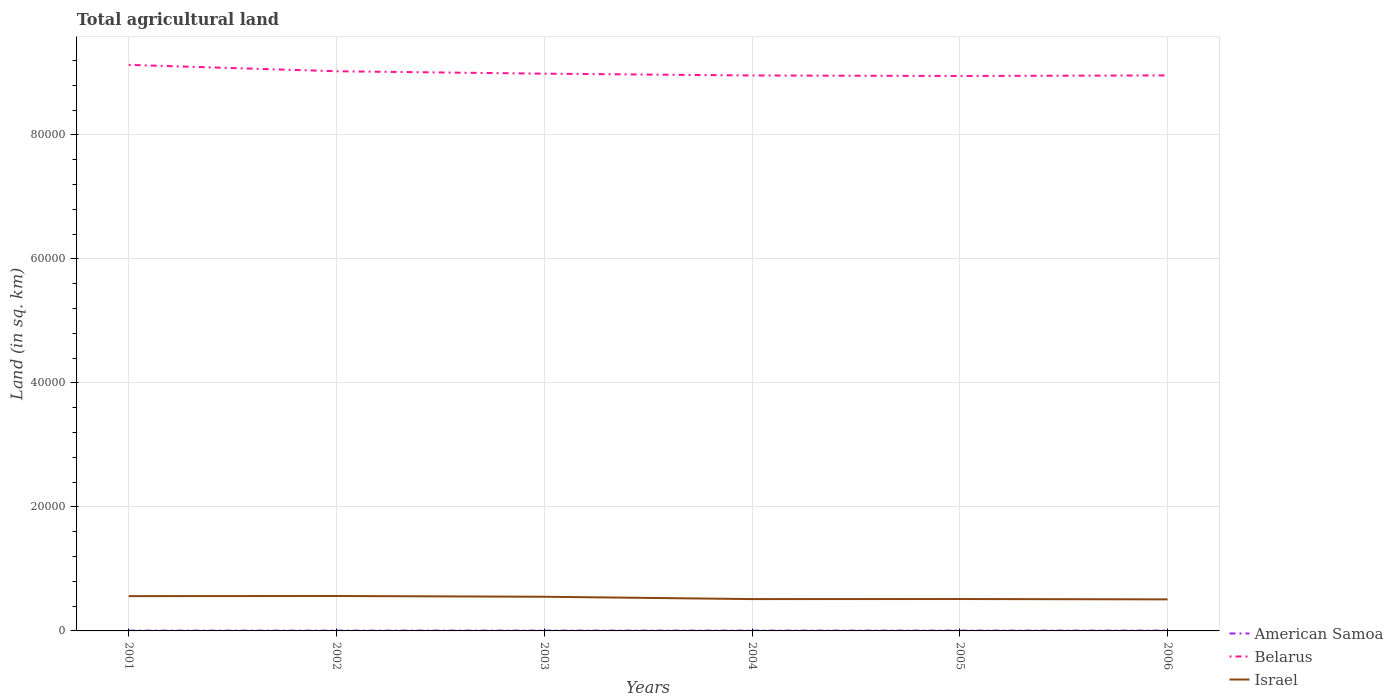How many different coloured lines are there?
Your response must be concise. 3. Does the line corresponding to Belarus intersect with the line corresponding to American Samoa?
Provide a succinct answer. No. Is the number of lines equal to the number of legend labels?
Make the answer very short. Yes. Across all years, what is the maximum total agricultural land in Israel?
Offer a terse response. 5088. In which year was the total agricultural land in Belarus maximum?
Give a very brief answer. 2005. What is the total total agricultural land in American Samoa in the graph?
Make the answer very short. 0.4. What is the difference between the highest and the second highest total agricultural land in Belarus?
Your response must be concise. 1790. Is the total agricultural land in Belarus strictly greater than the total agricultural land in American Samoa over the years?
Your answer should be compact. No. How many lines are there?
Ensure brevity in your answer.  3. How many years are there in the graph?
Give a very brief answer. 6. What is the difference between two consecutive major ticks on the Y-axis?
Your response must be concise. 2.00e+04. Does the graph contain any zero values?
Provide a short and direct response. No. Does the graph contain grids?
Your answer should be compact. Yes. How are the legend labels stacked?
Your response must be concise. Vertical. What is the title of the graph?
Give a very brief answer. Total agricultural land. What is the label or title of the Y-axis?
Offer a very short reply. Land (in sq. km). What is the Land (in sq. km) of Belarus in 2001?
Provide a short and direct response. 9.13e+04. What is the Land (in sq. km) in Israel in 2001?
Your answer should be very brief. 5610. What is the Land (in sq. km) in Belarus in 2002?
Offer a terse response. 9.02e+04. What is the Land (in sq. km) of Israel in 2002?
Offer a very short reply. 5630. What is the Land (in sq. km) of American Samoa in 2003?
Your response must be concise. 50.4. What is the Land (in sq. km) in Belarus in 2003?
Provide a succinct answer. 8.99e+04. What is the Land (in sq. km) of Israel in 2003?
Your answer should be very brief. 5510. What is the Land (in sq. km) in American Samoa in 2004?
Your answer should be compact. 50. What is the Land (in sq. km) in Belarus in 2004?
Provide a short and direct response. 8.96e+04. What is the Land (in sq. km) of Israel in 2004?
Provide a succinct answer. 5135. What is the Land (in sq. km) of American Samoa in 2005?
Make the answer very short. 50. What is the Land (in sq. km) in Belarus in 2005?
Your response must be concise. 8.95e+04. What is the Land (in sq. km) of Israel in 2005?
Ensure brevity in your answer.  5145. What is the Land (in sq. km) of American Samoa in 2006?
Ensure brevity in your answer.  50. What is the Land (in sq. km) of Belarus in 2006?
Offer a very short reply. 8.96e+04. What is the Land (in sq. km) of Israel in 2006?
Keep it short and to the point. 5088. Across all years, what is the maximum Land (in sq. km) in American Samoa?
Provide a short and direct response. 50.4. Across all years, what is the maximum Land (in sq. km) of Belarus?
Give a very brief answer. 9.13e+04. Across all years, what is the maximum Land (in sq. km) in Israel?
Offer a very short reply. 5630. Across all years, what is the minimum Land (in sq. km) of Belarus?
Give a very brief answer. 8.95e+04. Across all years, what is the minimum Land (in sq. km) in Israel?
Ensure brevity in your answer.  5088. What is the total Land (in sq. km) in American Samoa in the graph?
Your answer should be compact. 290.4. What is the total Land (in sq. km) in Belarus in the graph?
Your answer should be compact. 5.40e+05. What is the total Land (in sq. km) of Israel in the graph?
Provide a short and direct response. 3.21e+04. What is the difference between the Land (in sq. km) in American Samoa in 2001 and that in 2002?
Give a very brief answer. 0. What is the difference between the Land (in sq. km) of Belarus in 2001 and that in 2002?
Make the answer very short. 1030. What is the difference between the Land (in sq. km) of American Samoa in 2001 and that in 2003?
Ensure brevity in your answer.  -5.4. What is the difference between the Land (in sq. km) in Belarus in 2001 and that in 2003?
Keep it short and to the point. 1420. What is the difference between the Land (in sq. km) in American Samoa in 2001 and that in 2004?
Ensure brevity in your answer.  -5. What is the difference between the Land (in sq. km) in Belarus in 2001 and that in 2004?
Your answer should be compact. 1710. What is the difference between the Land (in sq. km) in Israel in 2001 and that in 2004?
Offer a very short reply. 475. What is the difference between the Land (in sq. km) of Belarus in 2001 and that in 2005?
Provide a short and direct response. 1790. What is the difference between the Land (in sq. km) in Israel in 2001 and that in 2005?
Provide a succinct answer. 465. What is the difference between the Land (in sq. km) of Belarus in 2001 and that in 2006?
Ensure brevity in your answer.  1700. What is the difference between the Land (in sq. km) of Israel in 2001 and that in 2006?
Offer a terse response. 522. What is the difference between the Land (in sq. km) in American Samoa in 2002 and that in 2003?
Keep it short and to the point. -5.4. What is the difference between the Land (in sq. km) of Belarus in 2002 and that in 2003?
Provide a short and direct response. 390. What is the difference between the Land (in sq. km) in Israel in 2002 and that in 2003?
Ensure brevity in your answer.  120. What is the difference between the Land (in sq. km) of American Samoa in 2002 and that in 2004?
Offer a very short reply. -5. What is the difference between the Land (in sq. km) of Belarus in 2002 and that in 2004?
Your answer should be very brief. 680. What is the difference between the Land (in sq. km) of Israel in 2002 and that in 2004?
Provide a succinct answer. 495. What is the difference between the Land (in sq. km) in Belarus in 2002 and that in 2005?
Provide a short and direct response. 760. What is the difference between the Land (in sq. km) in Israel in 2002 and that in 2005?
Your response must be concise. 485. What is the difference between the Land (in sq. km) of Belarus in 2002 and that in 2006?
Give a very brief answer. 670. What is the difference between the Land (in sq. km) in Israel in 2002 and that in 2006?
Keep it short and to the point. 542. What is the difference between the Land (in sq. km) in American Samoa in 2003 and that in 2004?
Provide a succinct answer. 0.4. What is the difference between the Land (in sq. km) of Belarus in 2003 and that in 2004?
Provide a short and direct response. 290. What is the difference between the Land (in sq. km) in Israel in 2003 and that in 2004?
Keep it short and to the point. 375. What is the difference between the Land (in sq. km) of American Samoa in 2003 and that in 2005?
Make the answer very short. 0.4. What is the difference between the Land (in sq. km) of Belarus in 2003 and that in 2005?
Your response must be concise. 370. What is the difference between the Land (in sq. km) in Israel in 2003 and that in 2005?
Your answer should be very brief. 365. What is the difference between the Land (in sq. km) of American Samoa in 2003 and that in 2006?
Your answer should be compact. 0.4. What is the difference between the Land (in sq. km) of Belarus in 2003 and that in 2006?
Keep it short and to the point. 280. What is the difference between the Land (in sq. km) of Israel in 2003 and that in 2006?
Provide a short and direct response. 422. What is the difference between the Land (in sq. km) in American Samoa in 2004 and that in 2005?
Your answer should be compact. 0. What is the difference between the Land (in sq. km) in Israel in 2004 and that in 2005?
Your response must be concise. -10. What is the difference between the Land (in sq. km) of American Samoa in 2005 and that in 2006?
Your answer should be very brief. 0. What is the difference between the Land (in sq. km) in Belarus in 2005 and that in 2006?
Your answer should be compact. -90. What is the difference between the Land (in sq. km) in Israel in 2005 and that in 2006?
Your answer should be very brief. 57. What is the difference between the Land (in sq. km) in American Samoa in 2001 and the Land (in sq. km) in Belarus in 2002?
Offer a terse response. -9.02e+04. What is the difference between the Land (in sq. km) in American Samoa in 2001 and the Land (in sq. km) in Israel in 2002?
Ensure brevity in your answer.  -5585. What is the difference between the Land (in sq. km) in Belarus in 2001 and the Land (in sq. km) in Israel in 2002?
Keep it short and to the point. 8.56e+04. What is the difference between the Land (in sq. km) in American Samoa in 2001 and the Land (in sq. km) in Belarus in 2003?
Give a very brief answer. -8.98e+04. What is the difference between the Land (in sq. km) of American Samoa in 2001 and the Land (in sq. km) of Israel in 2003?
Provide a short and direct response. -5465. What is the difference between the Land (in sq. km) of Belarus in 2001 and the Land (in sq. km) of Israel in 2003?
Ensure brevity in your answer.  8.58e+04. What is the difference between the Land (in sq. km) in American Samoa in 2001 and the Land (in sq. km) in Belarus in 2004?
Keep it short and to the point. -8.95e+04. What is the difference between the Land (in sq. km) of American Samoa in 2001 and the Land (in sq. km) of Israel in 2004?
Provide a short and direct response. -5090. What is the difference between the Land (in sq. km) of Belarus in 2001 and the Land (in sq. km) of Israel in 2004?
Give a very brief answer. 8.61e+04. What is the difference between the Land (in sq. km) in American Samoa in 2001 and the Land (in sq. km) in Belarus in 2005?
Your answer should be very brief. -8.94e+04. What is the difference between the Land (in sq. km) in American Samoa in 2001 and the Land (in sq. km) in Israel in 2005?
Offer a very short reply. -5100. What is the difference between the Land (in sq. km) of Belarus in 2001 and the Land (in sq. km) of Israel in 2005?
Offer a very short reply. 8.61e+04. What is the difference between the Land (in sq. km) in American Samoa in 2001 and the Land (in sq. km) in Belarus in 2006?
Your answer should be very brief. -8.95e+04. What is the difference between the Land (in sq. km) of American Samoa in 2001 and the Land (in sq. km) of Israel in 2006?
Your response must be concise. -5043. What is the difference between the Land (in sq. km) in Belarus in 2001 and the Land (in sq. km) in Israel in 2006?
Offer a very short reply. 8.62e+04. What is the difference between the Land (in sq. km) in American Samoa in 2002 and the Land (in sq. km) in Belarus in 2003?
Provide a succinct answer. -8.98e+04. What is the difference between the Land (in sq. km) in American Samoa in 2002 and the Land (in sq. km) in Israel in 2003?
Make the answer very short. -5465. What is the difference between the Land (in sq. km) in Belarus in 2002 and the Land (in sq. km) in Israel in 2003?
Provide a short and direct response. 8.47e+04. What is the difference between the Land (in sq. km) in American Samoa in 2002 and the Land (in sq. km) in Belarus in 2004?
Ensure brevity in your answer.  -8.95e+04. What is the difference between the Land (in sq. km) of American Samoa in 2002 and the Land (in sq. km) of Israel in 2004?
Your response must be concise. -5090. What is the difference between the Land (in sq. km) in Belarus in 2002 and the Land (in sq. km) in Israel in 2004?
Your response must be concise. 8.51e+04. What is the difference between the Land (in sq. km) of American Samoa in 2002 and the Land (in sq. km) of Belarus in 2005?
Offer a very short reply. -8.94e+04. What is the difference between the Land (in sq. km) in American Samoa in 2002 and the Land (in sq. km) in Israel in 2005?
Keep it short and to the point. -5100. What is the difference between the Land (in sq. km) in Belarus in 2002 and the Land (in sq. km) in Israel in 2005?
Offer a very short reply. 8.51e+04. What is the difference between the Land (in sq. km) in American Samoa in 2002 and the Land (in sq. km) in Belarus in 2006?
Make the answer very short. -8.95e+04. What is the difference between the Land (in sq. km) in American Samoa in 2002 and the Land (in sq. km) in Israel in 2006?
Your response must be concise. -5043. What is the difference between the Land (in sq. km) of Belarus in 2002 and the Land (in sq. km) of Israel in 2006?
Provide a succinct answer. 8.52e+04. What is the difference between the Land (in sq. km) in American Samoa in 2003 and the Land (in sq. km) in Belarus in 2004?
Offer a very short reply. -8.95e+04. What is the difference between the Land (in sq. km) of American Samoa in 2003 and the Land (in sq. km) of Israel in 2004?
Provide a succinct answer. -5084.6. What is the difference between the Land (in sq. km) in Belarus in 2003 and the Land (in sq. km) in Israel in 2004?
Your response must be concise. 8.47e+04. What is the difference between the Land (in sq. km) in American Samoa in 2003 and the Land (in sq. km) in Belarus in 2005?
Your response must be concise. -8.94e+04. What is the difference between the Land (in sq. km) in American Samoa in 2003 and the Land (in sq. km) in Israel in 2005?
Your response must be concise. -5094.6. What is the difference between the Land (in sq. km) in Belarus in 2003 and the Land (in sq. km) in Israel in 2005?
Ensure brevity in your answer.  8.47e+04. What is the difference between the Land (in sq. km) in American Samoa in 2003 and the Land (in sq. km) in Belarus in 2006?
Your response must be concise. -8.95e+04. What is the difference between the Land (in sq. km) in American Samoa in 2003 and the Land (in sq. km) in Israel in 2006?
Provide a short and direct response. -5037.6. What is the difference between the Land (in sq. km) in Belarus in 2003 and the Land (in sq. km) in Israel in 2006?
Your response must be concise. 8.48e+04. What is the difference between the Land (in sq. km) in American Samoa in 2004 and the Land (in sq. km) in Belarus in 2005?
Keep it short and to the point. -8.94e+04. What is the difference between the Land (in sq. km) of American Samoa in 2004 and the Land (in sq. km) of Israel in 2005?
Offer a terse response. -5095. What is the difference between the Land (in sq. km) of Belarus in 2004 and the Land (in sq. km) of Israel in 2005?
Provide a short and direct response. 8.44e+04. What is the difference between the Land (in sq. km) of American Samoa in 2004 and the Land (in sq. km) of Belarus in 2006?
Provide a short and direct response. -8.95e+04. What is the difference between the Land (in sq. km) of American Samoa in 2004 and the Land (in sq. km) of Israel in 2006?
Give a very brief answer. -5038. What is the difference between the Land (in sq. km) of Belarus in 2004 and the Land (in sq. km) of Israel in 2006?
Provide a succinct answer. 8.45e+04. What is the difference between the Land (in sq. km) of American Samoa in 2005 and the Land (in sq. km) of Belarus in 2006?
Your answer should be compact. -8.95e+04. What is the difference between the Land (in sq. km) of American Samoa in 2005 and the Land (in sq. km) of Israel in 2006?
Provide a succinct answer. -5038. What is the difference between the Land (in sq. km) of Belarus in 2005 and the Land (in sq. km) of Israel in 2006?
Make the answer very short. 8.44e+04. What is the average Land (in sq. km) of American Samoa per year?
Your answer should be compact. 48.4. What is the average Land (in sq. km) in Belarus per year?
Your answer should be compact. 9.00e+04. What is the average Land (in sq. km) in Israel per year?
Provide a succinct answer. 5353. In the year 2001, what is the difference between the Land (in sq. km) of American Samoa and Land (in sq. km) of Belarus?
Offer a very short reply. -9.12e+04. In the year 2001, what is the difference between the Land (in sq. km) in American Samoa and Land (in sq. km) in Israel?
Give a very brief answer. -5565. In the year 2001, what is the difference between the Land (in sq. km) in Belarus and Land (in sq. km) in Israel?
Offer a terse response. 8.57e+04. In the year 2002, what is the difference between the Land (in sq. km) of American Samoa and Land (in sq. km) of Belarus?
Your answer should be very brief. -9.02e+04. In the year 2002, what is the difference between the Land (in sq. km) in American Samoa and Land (in sq. km) in Israel?
Provide a short and direct response. -5585. In the year 2002, what is the difference between the Land (in sq. km) in Belarus and Land (in sq. km) in Israel?
Give a very brief answer. 8.46e+04. In the year 2003, what is the difference between the Land (in sq. km) in American Samoa and Land (in sq. km) in Belarus?
Your answer should be compact. -8.98e+04. In the year 2003, what is the difference between the Land (in sq. km) in American Samoa and Land (in sq. km) in Israel?
Ensure brevity in your answer.  -5459.6. In the year 2003, what is the difference between the Land (in sq. km) of Belarus and Land (in sq. km) of Israel?
Your answer should be compact. 8.44e+04. In the year 2004, what is the difference between the Land (in sq. km) in American Samoa and Land (in sq. km) in Belarus?
Give a very brief answer. -8.95e+04. In the year 2004, what is the difference between the Land (in sq. km) in American Samoa and Land (in sq. km) in Israel?
Your answer should be very brief. -5085. In the year 2004, what is the difference between the Land (in sq. km) of Belarus and Land (in sq. km) of Israel?
Your answer should be compact. 8.44e+04. In the year 2005, what is the difference between the Land (in sq. km) in American Samoa and Land (in sq. km) in Belarus?
Provide a short and direct response. -8.94e+04. In the year 2005, what is the difference between the Land (in sq. km) in American Samoa and Land (in sq. km) in Israel?
Provide a short and direct response. -5095. In the year 2005, what is the difference between the Land (in sq. km) in Belarus and Land (in sq. km) in Israel?
Make the answer very short. 8.43e+04. In the year 2006, what is the difference between the Land (in sq. km) in American Samoa and Land (in sq. km) in Belarus?
Your answer should be very brief. -8.95e+04. In the year 2006, what is the difference between the Land (in sq. km) in American Samoa and Land (in sq. km) in Israel?
Your response must be concise. -5038. In the year 2006, what is the difference between the Land (in sq. km) in Belarus and Land (in sq. km) in Israel?
Provide a short and direct response. 8.45e+04. What is the ratio of the Land (in sq. km) in American Samoa in 2001 to that in 2002?
Offer a terse response. 1. What is the ratio of the Land (in sq. km) in Belarus in 2001 to that in 2002?
Make the answer very short. 1.01. What is the ratio of the Land (in sq. km) in American Samoa in 2001 to that in 2003?
Ensure brevity in your answer.  0.89. What is the ratio of the Land (in sq. km) of Belarus in 2001 to that in 2003?
Your answer should be very brief. 1.02. What is the ratio of the Land (in sq. km) in Israel in 2001 to that in 2003?
Provide a succinct answer. 1.02. What is the ratio of the Land (in sq. km) in Belarus in 2001 to that in 2004?
Offer a terse response. 1.02. What is the ratio of the Land (in sq. km) of Israel in 2001 to that in 2004?
Keep it short and to the point. 1.09. What is the ratio of the Land (in sq. km) of Belarus in 2001 to that in 2005?
Provide a short and direct response. 1.02. What is the ratio of the Land (in sq. km) in Israel in 2001 to that in 2005?
Provide a succinct answer. 1.09. What is the ratio of the Land (in sq. km) in American Samoa in 2001 to that in 2006?
Provide a succinct answer. 0.9. What is the ratio of the Land (in sq. km) in Israel in 2001 to that in 2006?
Your response must be concise. 1.1. What is the ratio of the Land (in sq. km) of American Samoa in 2002 to that in 2003?
Provide a short and direct response. 0.89. What is the ratio of the Land (in sq. km) of Israel in 2002 to that in 2003?
Your answer should be very brief. 1.02. What is the ratio of the Land (in sq. km) in Belarus in 2002 to that in 2004?
Provide a short and direct response. 1.01. What is the ratio of the Land (in sq. km) of Israel in 2002 to that in 2004?
Your response must be concise. 1.1. What is the ratio of the Land (in sq. km) of American Samoa in 2002 to that in 2005?
Make the answer very short. 0.9. What is the ratio of the Land (in sq. km) of Belarus in 2002 to that in 2005?
Your answer should be very brief. 1.01. What is the ratio of the Land (in sq. km) of Israel in 2002 to that in 2005?
Give a very brief answer. 1.09. What is the ratio of the Land (in sq. km) of Belarus in 2002 to that in 2006?
Make the answer very short. 1.01. What is the ratio of the Land (in sq. km) of Israel in 2002 to that in 2006?
Provide a short and direct response. 1.11. What is the ratio of the Land (in sq. km) in Belarus in 2003 to that in 2004?
Your answer should be compact. 1. What is the ratio of the Land (in sq. km) of Israel in 2003 to that in 2004?
Offer a very short reply. 1.07. What is the ratio of the Land (in sq. km) in American Samoa in 2003 to that in 2005?
Ensure brevity in your answer.  1.01. What is the ratio of the Land (in sq. km) in Israel in 2003 to that in 2005?
Give a very brief answer. 1.07. What is the ratio of the Land (in sq. km) in American Samoa in 2003 to that in 2006?
Make the answer very short. 1.01. What is the ratio of the Land (in sq. km) in Israel in 2003 to that in 2006?
Make the answer very short. 1.08. What is the ratio of the Land (in sq. km) of Belarus in 2004 to that in 2006?
Provide a short and direct response. 1. What is the ratio of the Land (in sq. km) of Israel in 2004 to that in 2006?
Provide a succinct answer. 1.01. What is the ratio of the Land (in sq. km) in Israel in 2005 to that in 2006?
Offer a terse response. 1.01. What is the difference between the highest and the second highest Land (in sq. km) in Belarus?
Make the answer very short. 1030. What is the difference between the highest and the lowest Land (in sq. km) of Belarus?
Provide a short and direct response. 1790. What is the difference between the highest and the lowest Land (in sq. km) in Israel?
Provide a succinct answer. 542. 